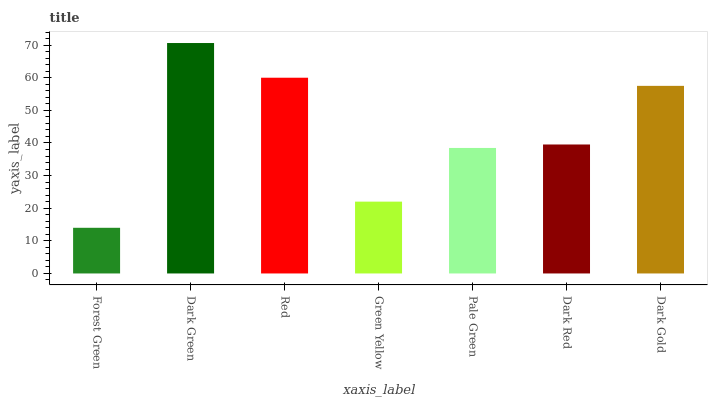Is Forest Green the minimum?
Answer yes or no. Yes. Is Dark Green the maximum?
Answer yes or no. Yes. Is Red the minimum?
Answer yes or no. No. Is Red the maximum?
Answer yes or no. No. Is Dark Green greater than Red?
Answer yes or no. Yes. Is Red less than Dark Green?
Answer yes or no. Yes. Is Red greater than Dark Green?
Answer yes or no. No. Is Dark Green less than Red?
Answer yes or no. No. Is Dark Red the high median?
Answer yes or no. Yes. Is Dark Red the low median?
Answer yes or no. Yes. Is Pale Green the high median?
Answer yes or no. No. Is Dark Gold the low median?
Answer yes or no. No. 